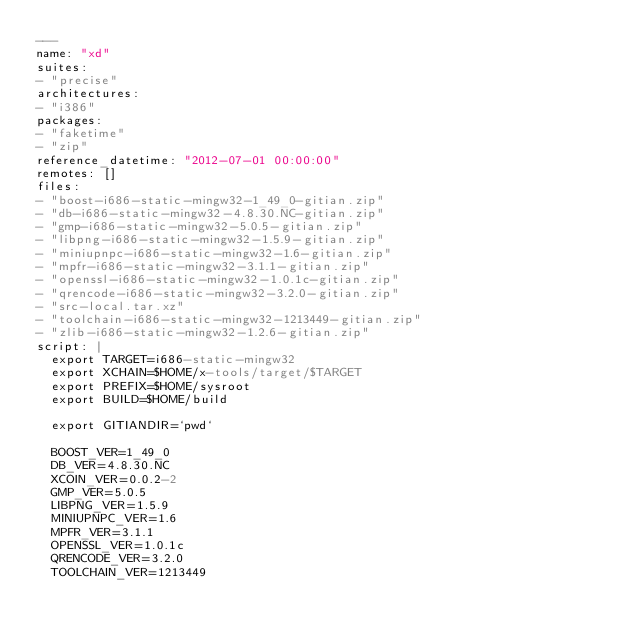<code> <loc_0><loc_0><loc_500><loc_500><_YAML_>---
name: "xd"
suites:
- "precise"
architectures:
- "i386"
packages:
- "faketime"
- "zip"
reference_datetime: "2012-07-01 00:00:00"
remotes: []
files:
- "boost-i686-static-mingw32-1_49_0-gitian.zip"
- "db-i686-static-mingw32-4.8.30.NC-gitian.zip"
- "gmp-i686-static-mingw32-5.0.5-gitian.zip"
- "libpng-i686-static-mingw32-1.5.9-gitian.zip"
- "miniupnpc-i686-static-mingw32-1.6-gitian.zip"
- "mpfr-i686-static-mingw32-3.1.1-gitian.zip"
- "openssl-i686-static-mingw32-1.0.1c-gitian.zip"
- "qrencode-i686-static-mingw32-3.2.0-gitian.zip"
- "src-local.tar.xz"
- "toolchain-i686-static-mingw32-1213449-gitian.zip"
- "zlib-i686-static-mingw32-1.2.6-gitian.zip"
script: |
  export TARGET=i686-static-mingw32
  export XCHAIN=$HOME/x-tools/target/$TARGET
  export PREFIX=$HOME/sysroot
  export BUILD=$HOME/build
  
  export GITIANDIR=`pwd`
  
  BOOST_VER=1_49_0
  DB_VER=4.8.30.NC
  XCOIN_VER=0.0.2-2
  GMP_VER=5.0.5
  LIBPNG_VER=1.5.9
  MINIUPNPC_VER=1.6
  MPFR_VER=3.1.1
  OPENSSL_VER=1.0.1c
  QRENCODE_VER=3.2.0
  TOOLCHAIN_VER=1213449</code> 